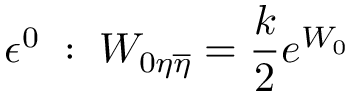<formula> <loc_0><loc_0><loc_500><loc_500>\epsilon ^ { 0 } \, \colon \, W _ { 0 \eta \overline { \eta } } = { \frac { k } { 2 } } e ^ { W _ { 0 } }</formula> 